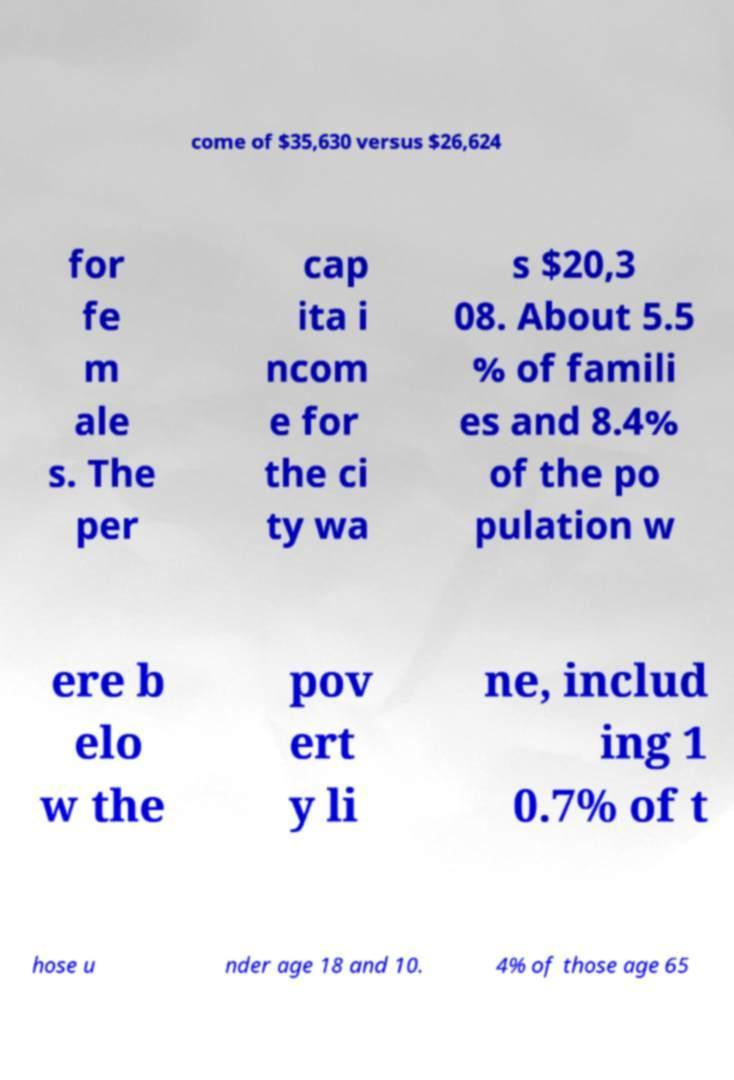What messages or text are displayed in this image? I need them in a readable, typed format. come of $35,630 versus $26,624 for fe m ale s. The per cap ita i ncom e for the ci ty wa s $20,3 08. About 5.5 % of famili es and 8.4% of the po pulation w ere b elo w the pov ert y li ne, includ ing 1 0.7% of t hose u nder age 18 and 10. 4% of those age 65 